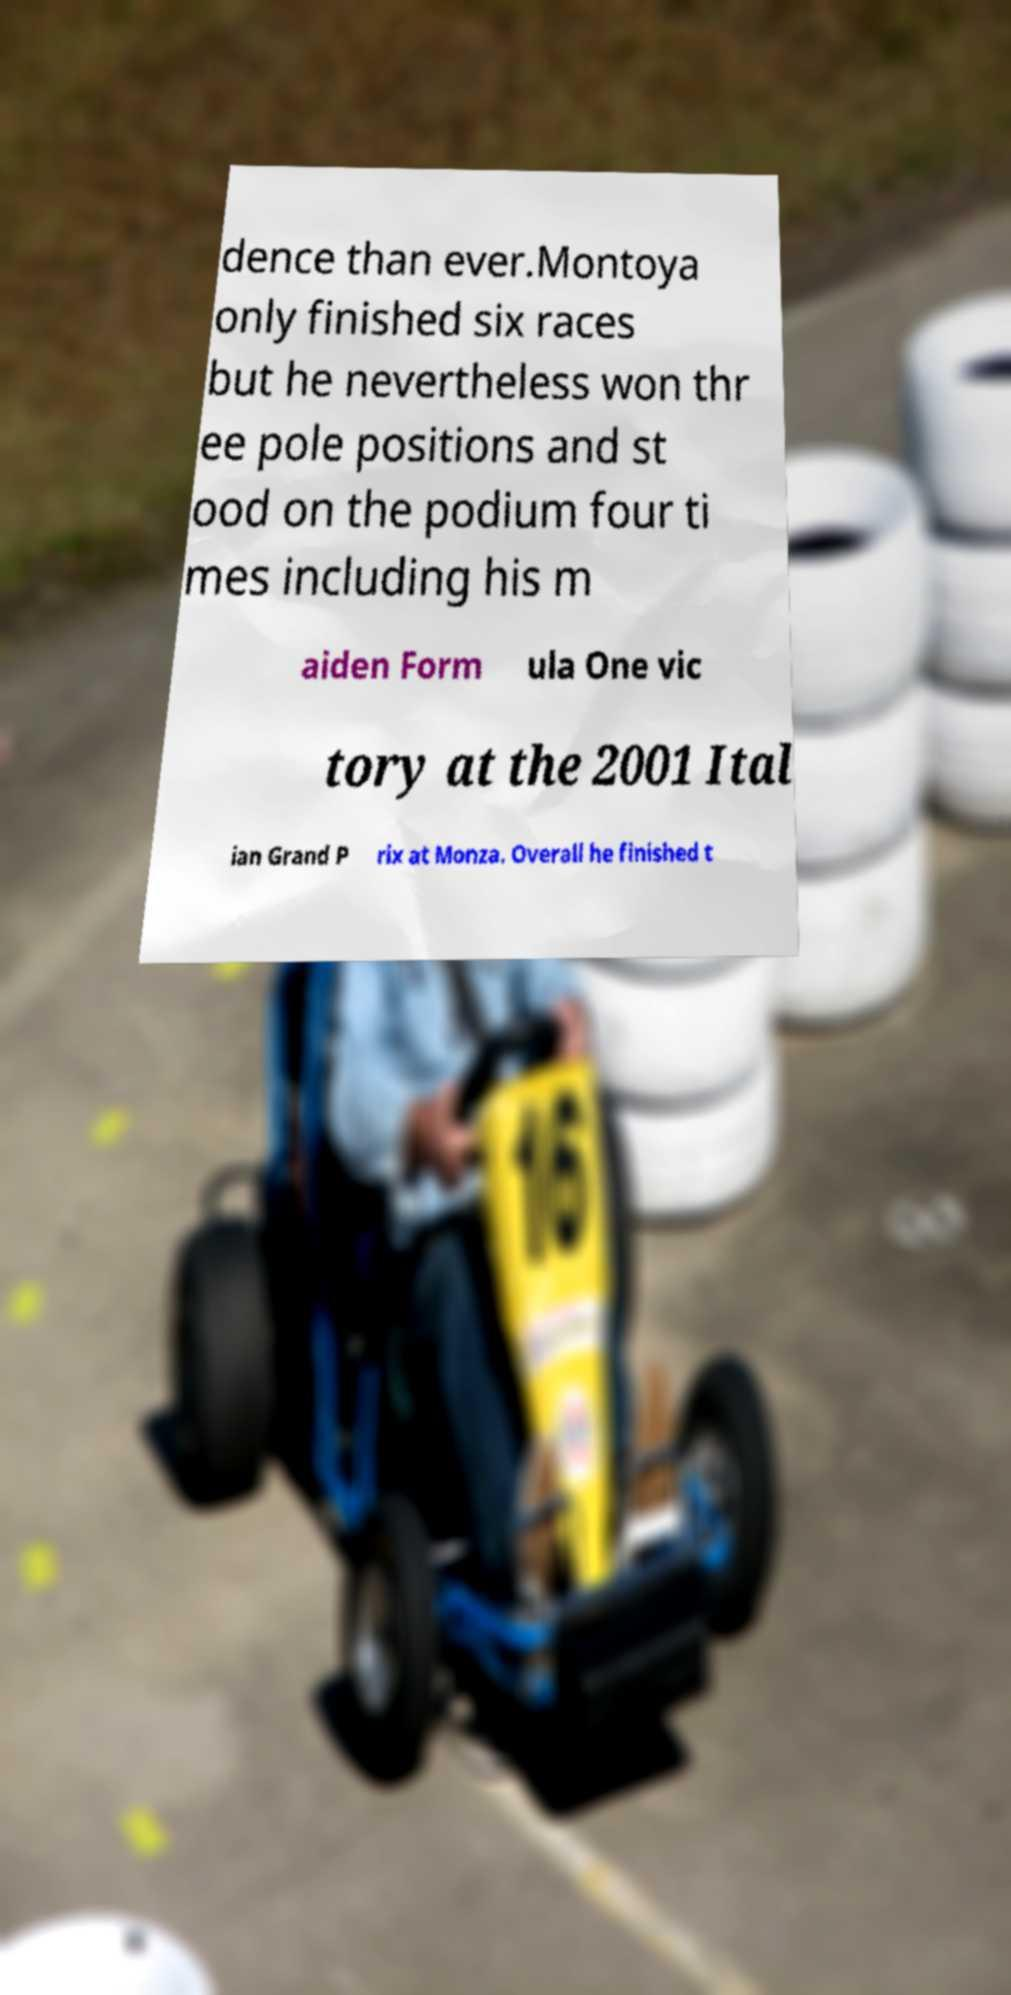Please identify and transcribe the text found in this image. dence than ever.Montoya only finished six races but he nevertheless won thr ee pole positions and st ood on the podium four ti mes including his m aiden Form ula One vic tory at the 2001 Ital ian Grand P rix at Monza. Overall he finished t 